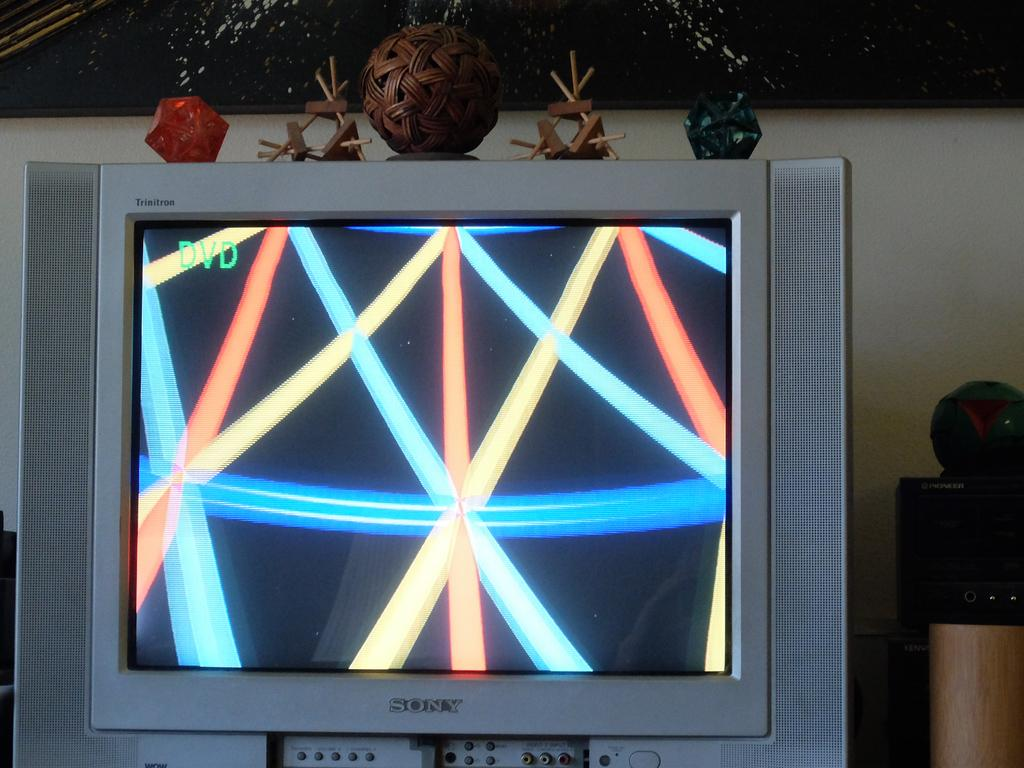Provide a one-sentence caption for the provided image. Sony silver flat screen television with lines on the screen. 